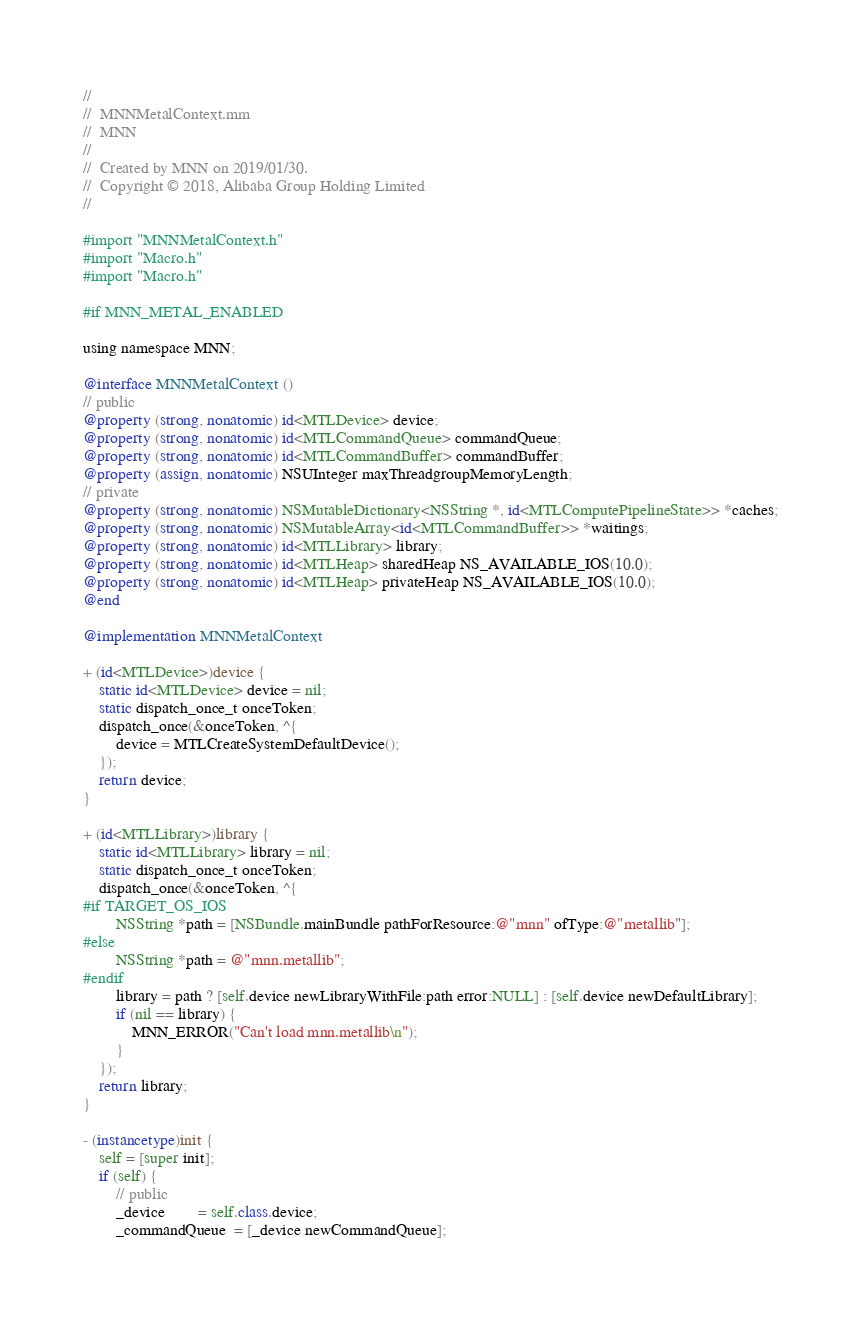<code> <loc_0><loc_0><loc_500><loc_500><_ObjectiveC_>//
//  MNNMetalContext.mm
//  MNN
//
//  Created by MNN on 2019/01/30.
//  Copyright © 2018, Alibaba Group Holding Limited
//

#import "MNNMetalContext.h"
#import "Macro.h"
#import "Macro.h"

#if MNN_METAL_ENABLED

using namespace MNN;

@interface MNNMetalContext ()
// public
@property (strong, nonatomic) id<MTLDevice> device;
@property (strong, nonatomic) id<MTLCommandQueue> commandQueue;
@property (strong, nonatomic) id<MTLCommandBuffer> commandBuffer;
@property (assign, nonatomic) NSUInteger maxThreadgroupMemoryLength;
// private
@property (strong, nonatomic) NSMutableDictionary<NSString *, id<MTLComputePipelineState>> *caches;
@property (strong, nonatomic) NSMutableArray<id<MTLCommandBuffer>> *waitings;
@property (strong, nonatomic) id<MTLLibrary> library;
@property (strong, nonatomic) id<MTLHeap> sharedHeap NS_AVAILABLE_IOS(10.0);
@property (strong, nonatomic) id<MTLHeap> privateHeap NS_AVAILABLE_IOS(10.0);
@end

@implementation MNNMetalContext

+ (id<MTLDevice>)device {
    static id<MTLDevice> device = nil;
    static dispatch_once_t onceToken;
    dispatch_once(&onceToken, ^{
        device = MTLCreateSystemDefaultDevice();
    });
    return device;
}

+ (id<MTLLibrary>)library {
    static id<MTLLibrary> library = nil;
    static dispatch_once_t onceToken;
    dispatch_once(&onceToken, ^{
#if TARGET_OS_IOS
        NSString *path = [NSBundle.mainBundle pathForResource:@"mnn" ofType:@"metallib"];
#else
        NSString *path = @"mnn.metallib";
#endif
        library = path ? [self.device newLibraryWithFile:path error:NULL] : [self.device newDefaultLibrary];
        if (nil == library) {
            MNN_ERROR("Can't load mnn.metallib\n");
        }
    });
    return library;
}

- (instancetype)init {
    self = [super init];
    if (self) {
        // public
        _device        = self.class.device;
        _commandQueue  = [_device newCommandQueue];</code> 